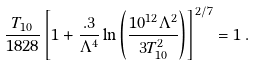Convert formula to latex. <formula><loc_0><loc_0><loc_500><loc_500>\frac { T _ { 1 0 } } { 1 8 2 8 } \left [ 1 + \frac { . 3 } { \Lambda ^ { 4 } } \ln \left ( \frac { 1 0 ^ { 1 2 } \Lambda ^ { 2 } } { 3 T _ { 1 0 } ^ { 2 } } \right ) \right ] ^ { 2 / 7 } = 1 \, .</formula> 